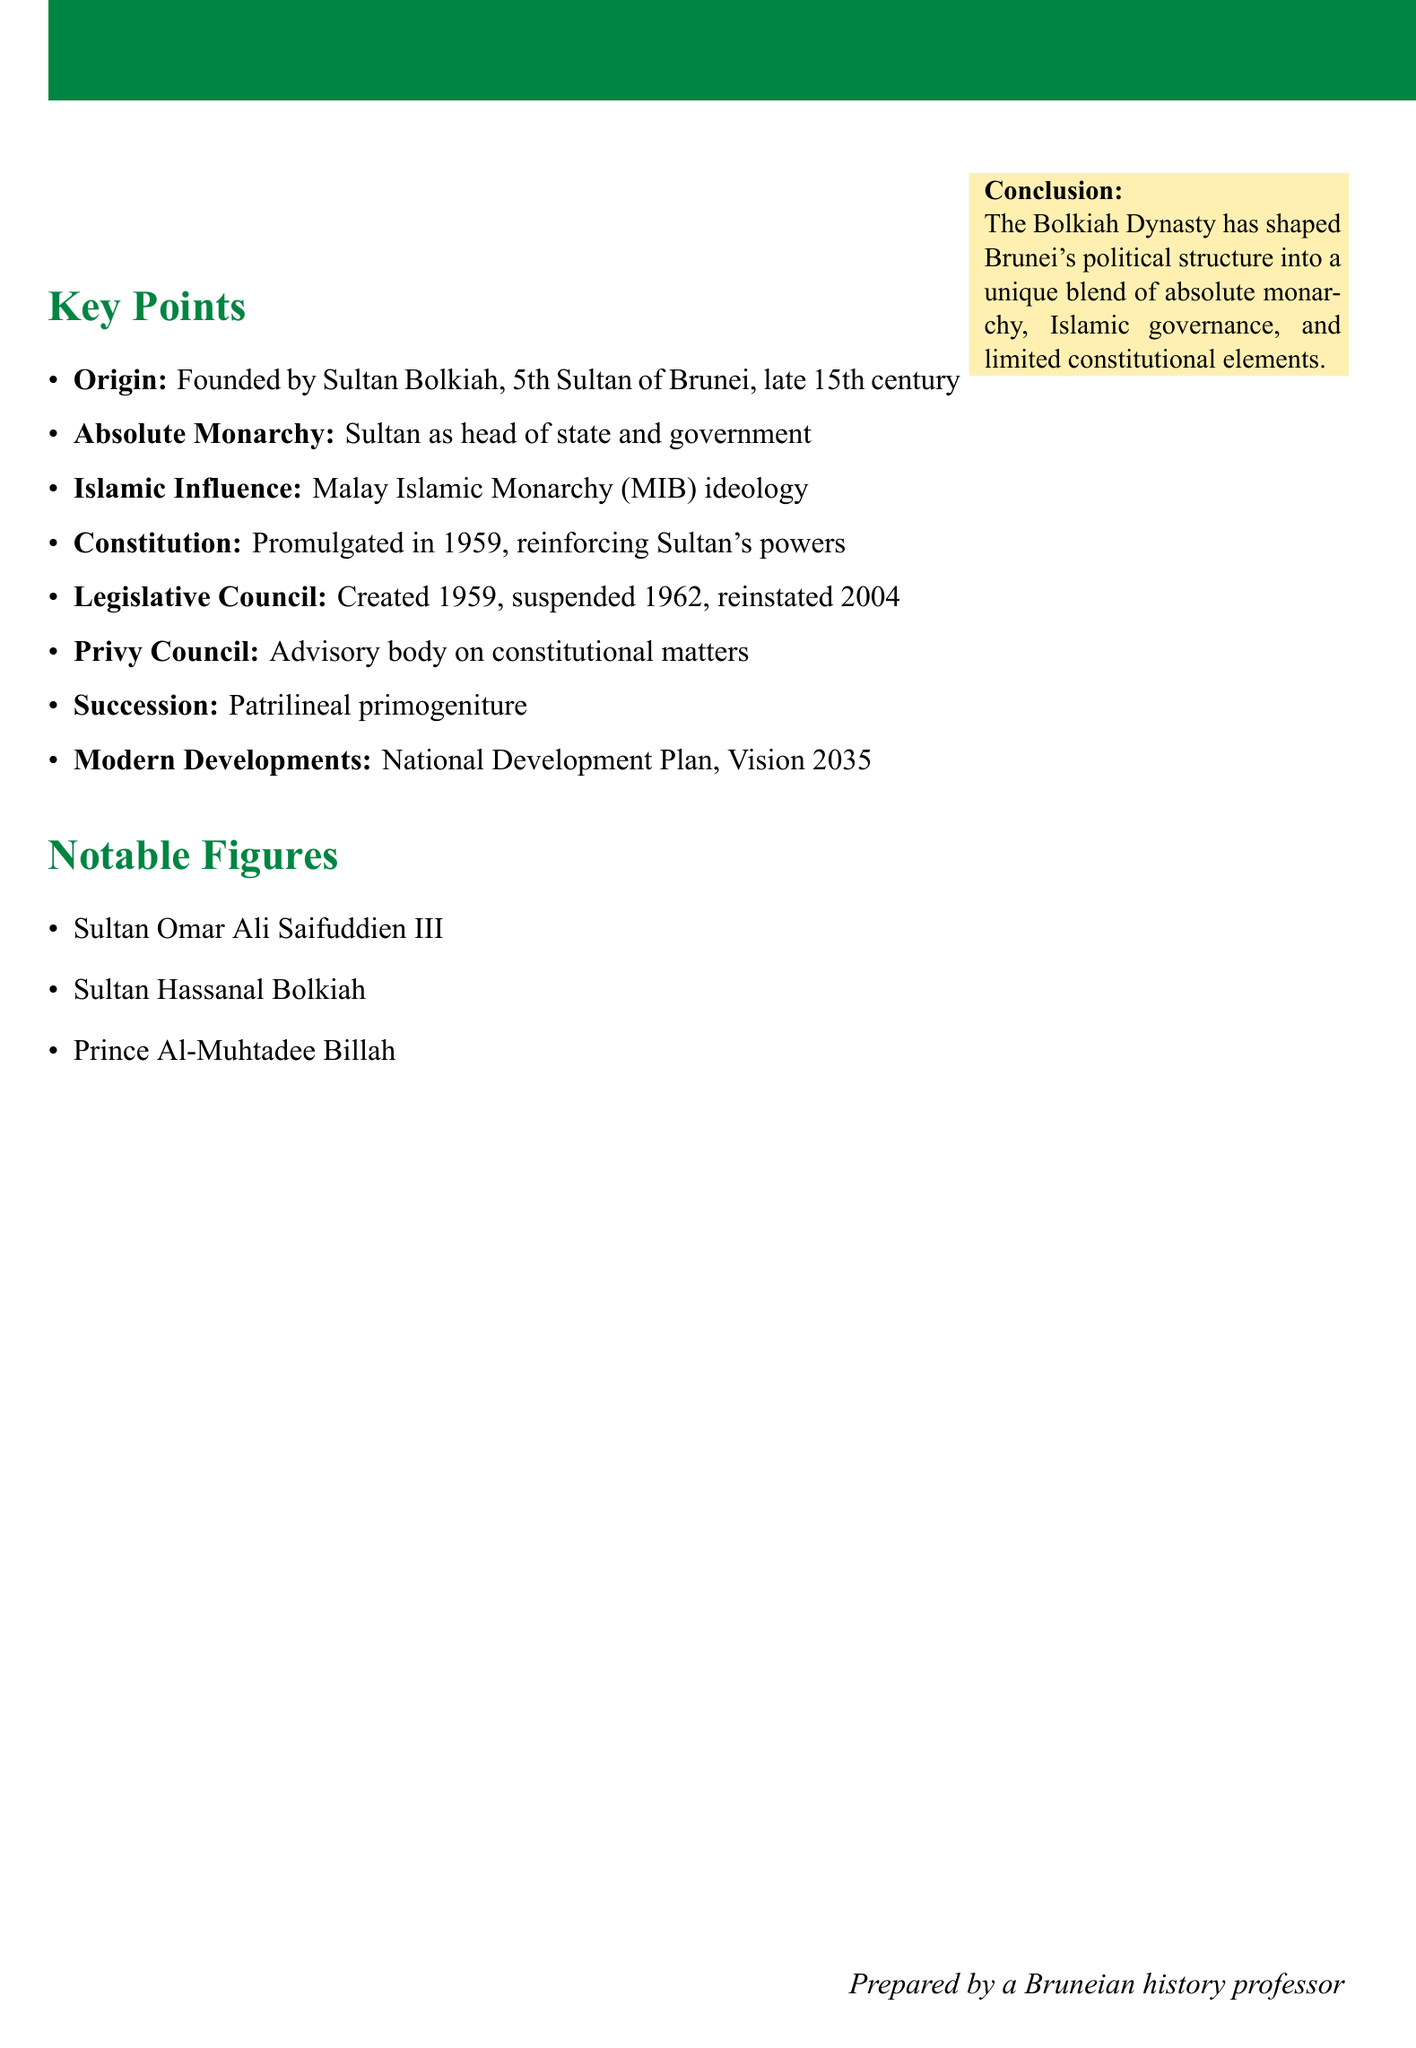What is the origin of the Bolkiah Dynasty? The origin details state that the Bolkiah Dynasty was founded by Sultan Bolkiah, the 5th Sultan of Brunei, in the late 15th century.
Answer: Founded by Sultan Bolkiah What type of monarchy was established by the Bolkiah Dynasty? The notes specify the establishment of an absolute monarchy system, with the Sultan as both head of state and head of government.
Answer: Absolute Monarchy When was the Constitution of Brunei promulgated? According to the document, the Constitution was promulgated in 1959.
Answer: 1959 Who is the current Sultan of Brunei? The document lists Sultan Hassanal Bolkiah as a notable figure in the Bolkiah Dynasty.
Answer: Sultan Hassanal Bolkiah What ideology was adopted through Islamic influence in Brunei's governance? The notes mention the adoption of the Malay Islamic Monarchy (MIB) ideology as a result of Islamic influence.
Answer: Malay Islamic Monarchy (MIB) What is the succession law implemented by the Bolkiah Dynasty? The document states that patrilineal primogeniture succession was implemented to ensure continuity of the Bolkiah Dynasty.
Answer: Patrilineal primogeniture What was the status of the Legislative Council in 1962? The notes state that the Legislative Council was suspended in 1962.
Answer: Suspended What major development plan was introduced under Sultan Hassanal Bolkiah? The document references the introduction of the National Development Plan and Vision 2035.
Answer: National Development Plan and Vision 2035 What is the conclusion about the influence of the Bolkiah Dynasty on Brunei's political structure? The conclusion summarizes that the Bolkiah Dynasty has shaped Brunei's political structure into a blend of absolute monarchy, Islamic governance, and limited constitutional elements.
Answer: Unique blend of absolute monarchy, Islamic governance, and limited constitutional elements 